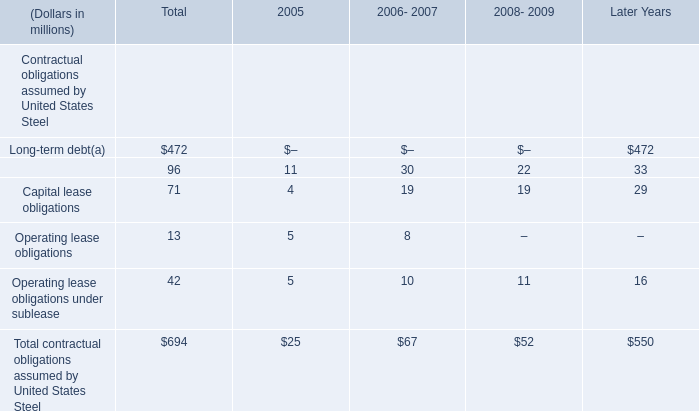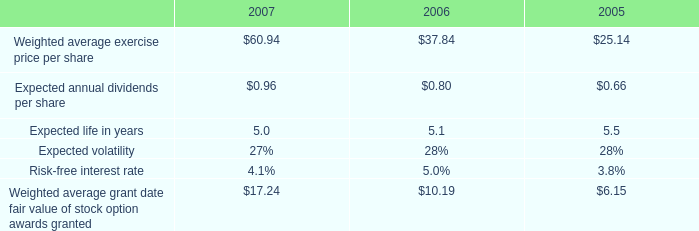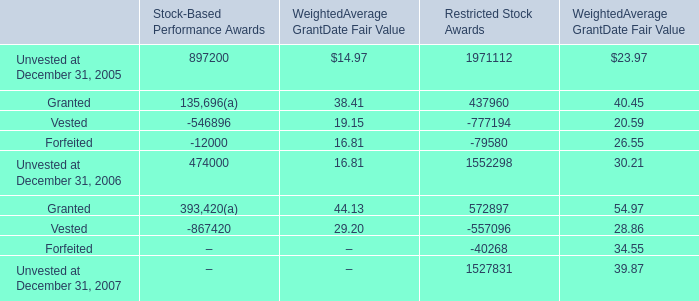what were total tax benefits realized for deductions during 2007 and 2006 in excess of the stock-based compensation expense for options exercised and other stock-based awards vested in millions? 
Computations: (30 + 36)
Answer: 66.0. 